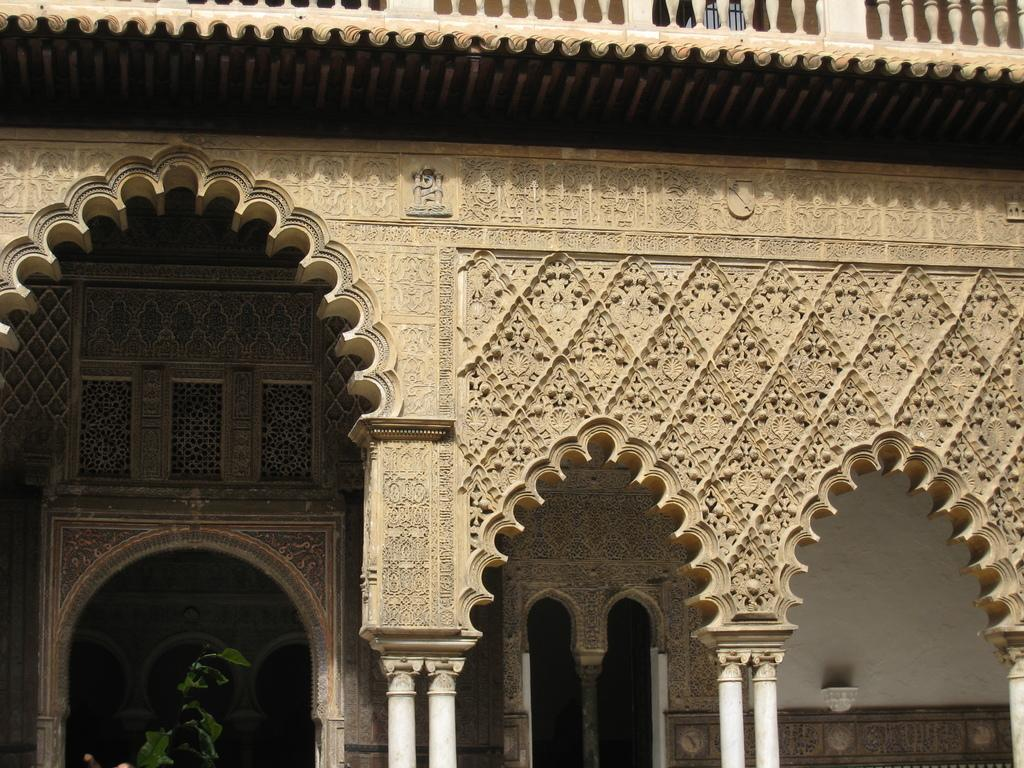What type of structure is present in the picture? There is a building in the picture. What architectural features can be seen on the building? There are pillars and an art design on the building. What other elements are present in the picture? There is a wall and a fence in the picture. How many snakes are slithering on the tongue of the person in the picture? There is no person or tongue present in the picture; it features a building with pillars, a wall, a fence, and an art design. 